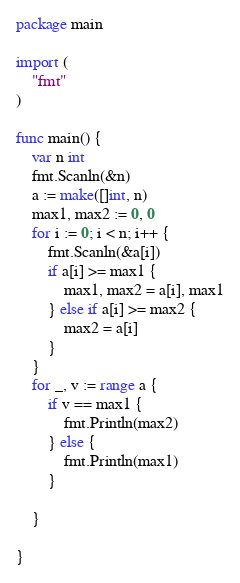Convert code to text. <code><loc_0><loc_0><loc_500><loc_500><_Go_>package main

import (
	"fmt"
)

func main() {
	var n int
	fmt.Scanln(&n)
	a := make([]int, n)
	max1, max2 := 0, 0
	for i := 0; i < n; i++ {
		fmt.Scanln(&a[i])
		if a[i] >= max1 {
			max1, max2 = a[i], max1
		} else if a[i] >= max2 {
			max2 = a[i]
		}
	}
	for _, v := range a {
		if v == max1 {
			fmt.Println(max2)
		} else {
			fmt.Println(max1)
		}

	}

}
</code> 